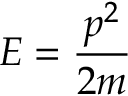<formula> <loc_0><loc_0><loc_500><loc_500>E = { \frac { p ^ { 2 } } { 2 m } }</formula> 